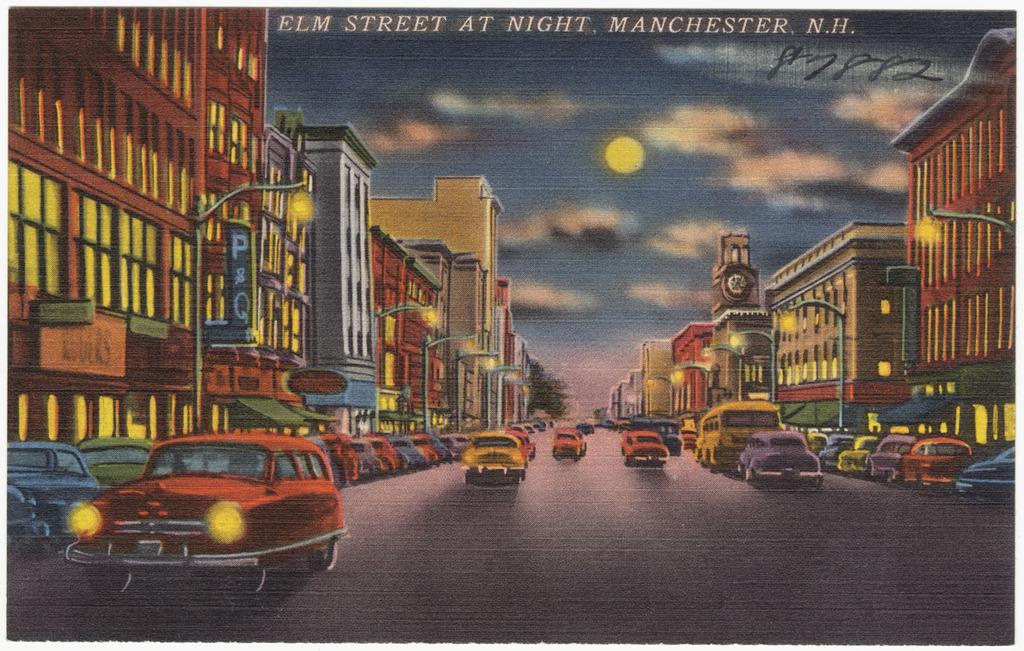Where is this located?
Give a very brief answer. Manchester, n.h. 